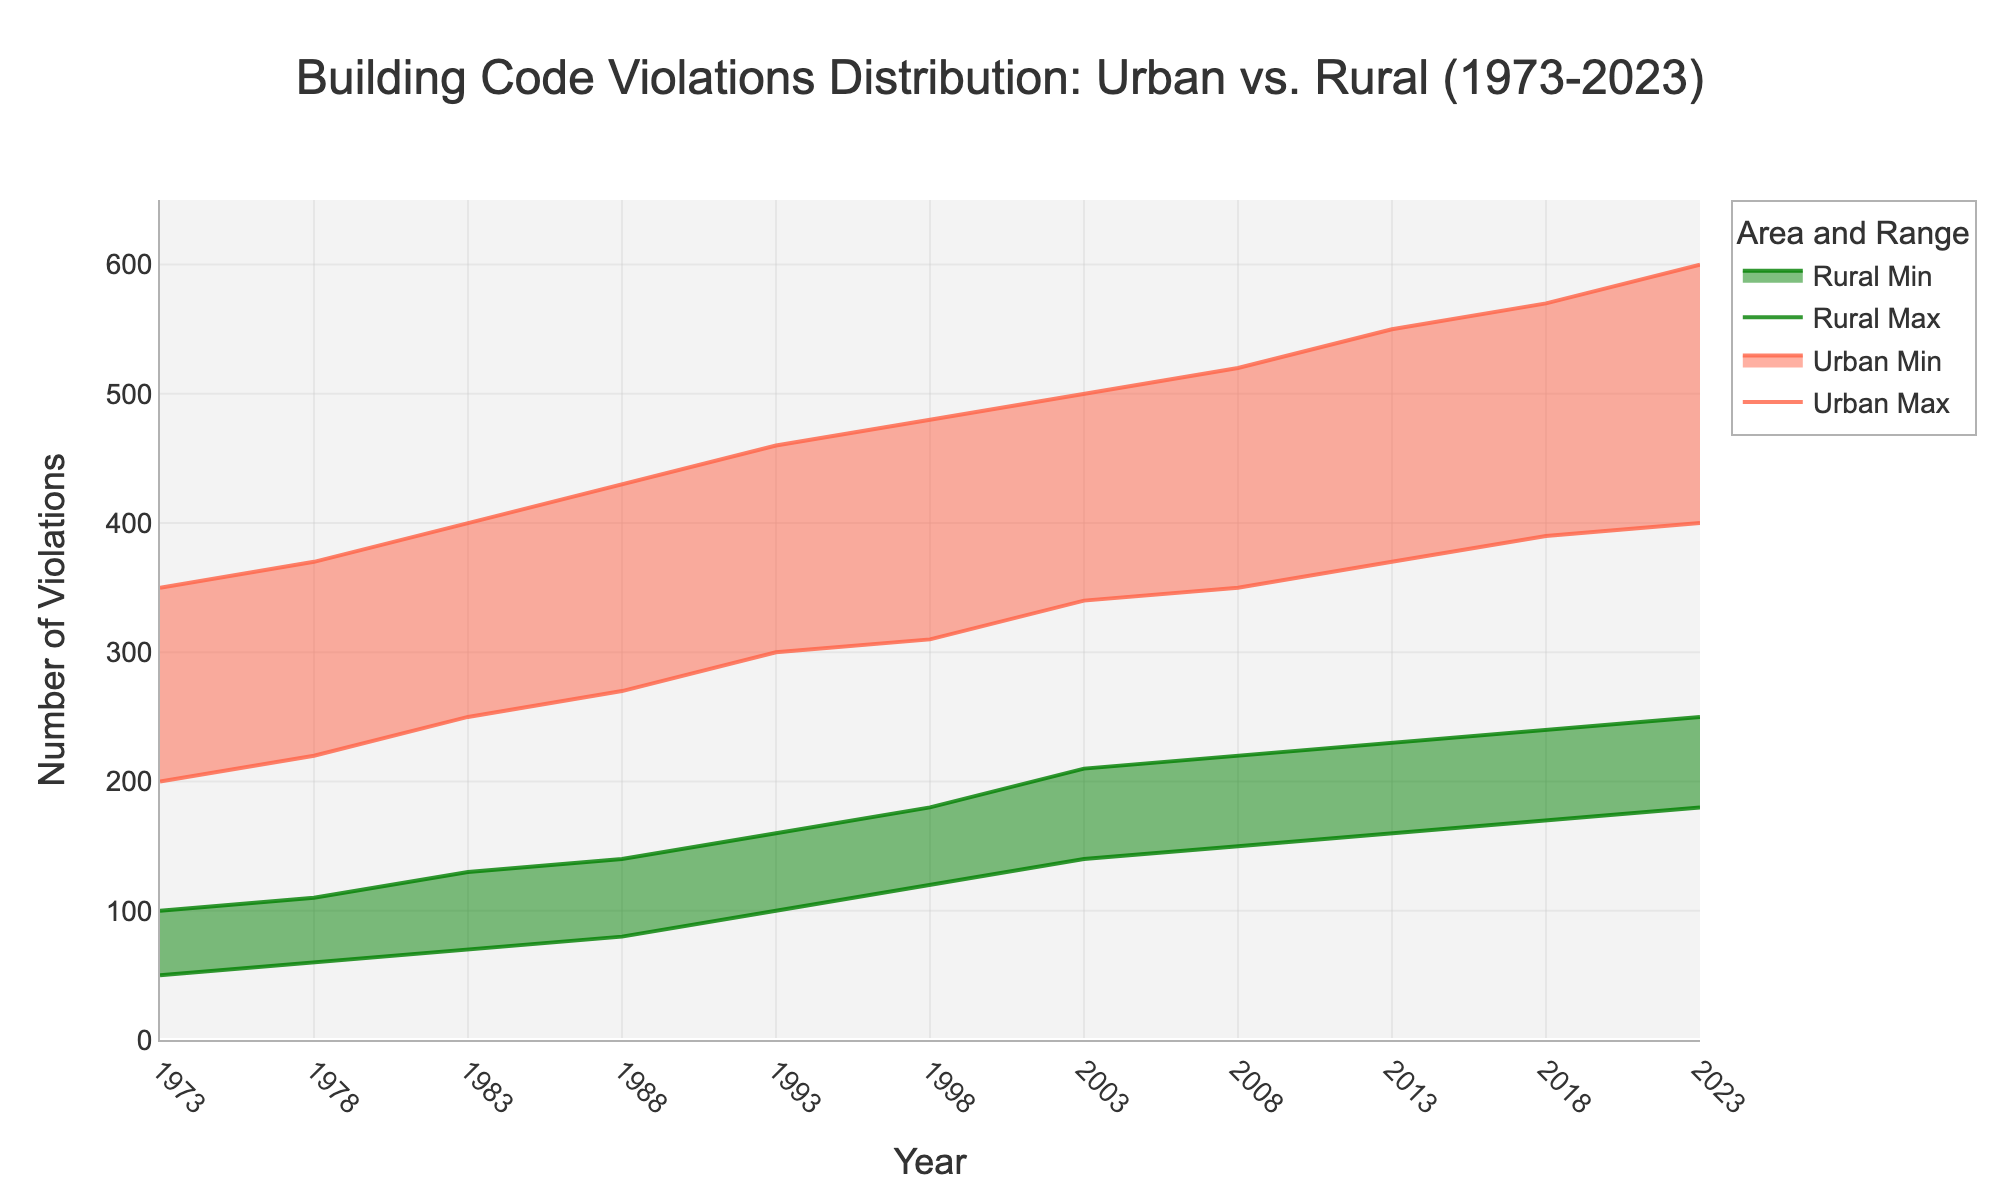What is the range of building code violations for urban areas in 1973? The range is determined by the difference between the maximum and minimum values for urban violations in 1973. The minimum is 200 and the maximum is 350. Therefore, the range is 350 - 200 = 150.
Answer: 150 Between which years did the maximum building code violations in urban areas increase by exactly 70? To find when there was an increase by 70 in urban maximum violations, look at the increments in the data. Between 1988 (430) and 1993 (460), the increase is 460 - 430 = 30. Between 2018 (570) and 2023 (600), the increase is 600 - 570 = 30. Therefore, no single interval has an exact increase of 70.
Answer: None In which year did the rural areas see their highest minimum violations, and what was the value? Looking at the minimum violations for rural areas, the highest value is found in 2023, which is 180.
Answer: 2023, 180 Did urban or rural areas have a wider range of violations in 2003? The range is calculated by subtracting the minimum value from the maximum value for both areas. For urban areas: 500 - 340 = 160. For rural areas: 210 - 140 = 70. The urban areas had a wider range.
Answer: Urban What was the average maximum building code violations for rural areas in the first five years (1973-1993)? Average is calculated by summing up the maximum values for the first five years and then dividing by the number of years. (100 + 110 + 130 + 140 + 160) / 5 = 640 / 5 = 128.
Answer: 128 Which year experienced the smallest increase in maximum building code violations for urban areas compared to the previous year? Compare the successive maximum values to find the smallest increase: The difference for each subsequent year are: 370-350=20 (1978), 400-370=30 (1983), 430-400=30 (1988), 460-430=30 (1993), 480-460=20 (1998), 500-480=20 (2003), 520-500=20 (2008), 550-520=30 (2013), 570-550=20 (2018), 600-570=30 (2023). The smallest increase is 20 (1978, 1998, 2003, 2008, 2018). The answer is 5 years.
Answer: Multiple Answers (1978, 1998, 2003, 2008, 2018) What is the difference in the range of violations between urban and rural areas in 2023? Calculate the range for both areas: Urban: 600 - 400 = 200. Rural: 250 - 180 = 70. Then, find the difference between these ranges: 200 - 70 = 130.
Answer: 130 Describe the trend of minimum building code violations in rural areas over the last 50 years. The minimum building code violations in rural areas have been increasing steadily over the years. Initial value in 1973 was 50, and it grew to 180 in 2023. This indicates a consistent rise in the minimum violations over time.
Answer: Increasing steadily Which year had the closest maximum building code violations between urban and rural areas and what were the values? Comparing the maximum violations for each year: 1973: 350 (Urban) - 100 (Rural) = 250. 1978: 370 - 110 = 260. 1983: 400 - 130 = 270. 1988: 430 - 140 = 290. 1993: 460 - 160 = 300. 1998: 480 - 180 = 300. 2003: 500 - 210 = 290. 2008: 520 - 220 = 300. 2013: 550 - 230 = 320. 2018: 570 - 240 = 330. 2023: 600 - 250 = 350. The closest difference is 250 in 1973.
Answer: 1973, Urban: 350, Rural: 100 